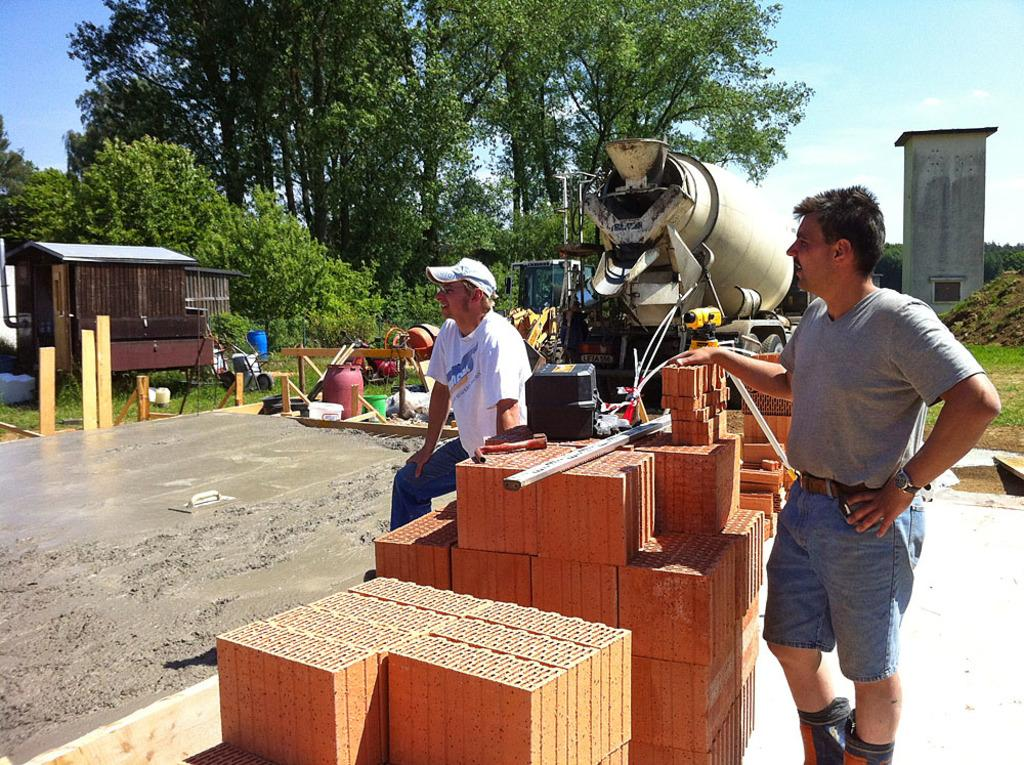How many people are present in the image? There are two persons in the image. What objects can be seen in the image besides the people? There are bricks, trees, a machine, and small sheds visible in the image. What can be seen in the background of the image? Trees and the sky are visible in the background of the image. Can you tell me how many streams are visible in the image? There are no streams present in the image. What type of iron is being used by the stranger in the image? There is no stranger present in the image, and therefore no iron being used. 